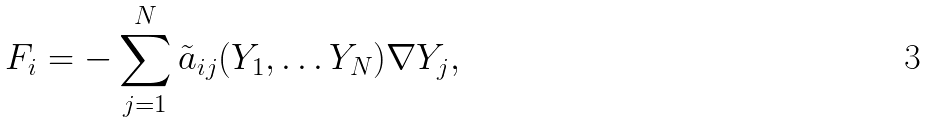<formula> <loc_0><loc_0><loc_500><loc_500>F _ { i } = - \sum ^ { N } _ { j = 1 } \tilde { a } _ { i j } ( Y _ { 1 } , \dots Y _ { N } ) \nabla Y _ { j } ,</formula> 